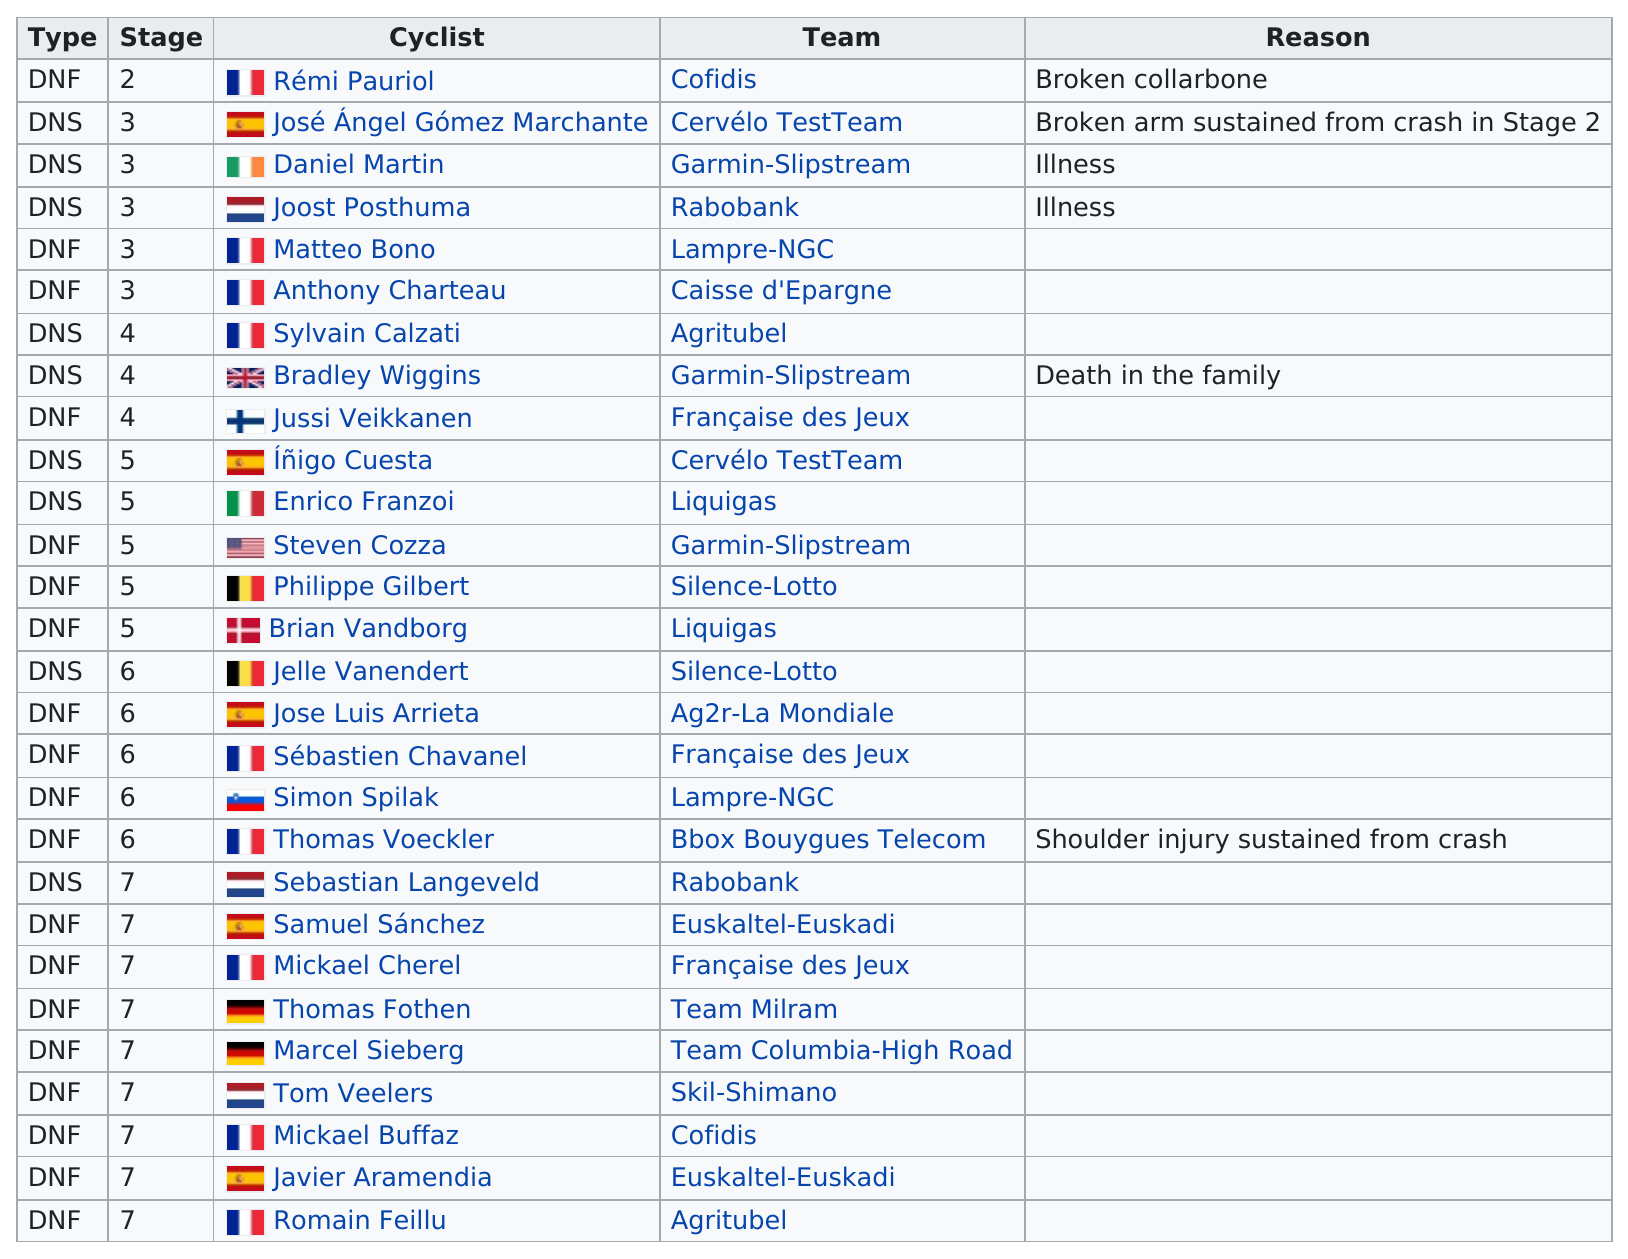Mention a couple of crucial points in this snapshot. José Ángel Gómez Marchante, a cyclist, withdrew from the competition after breaking his arm in a crash during stage 2. Matteo is followed by Anthony Charteau in the list of cyclists. Stage 7 had the most cyclists withdraw during the competition. Daniel Martin and Joost Posthuma withdrew from the race due to illness. Rémi Pauriol was the first person to withdraw from the race. 